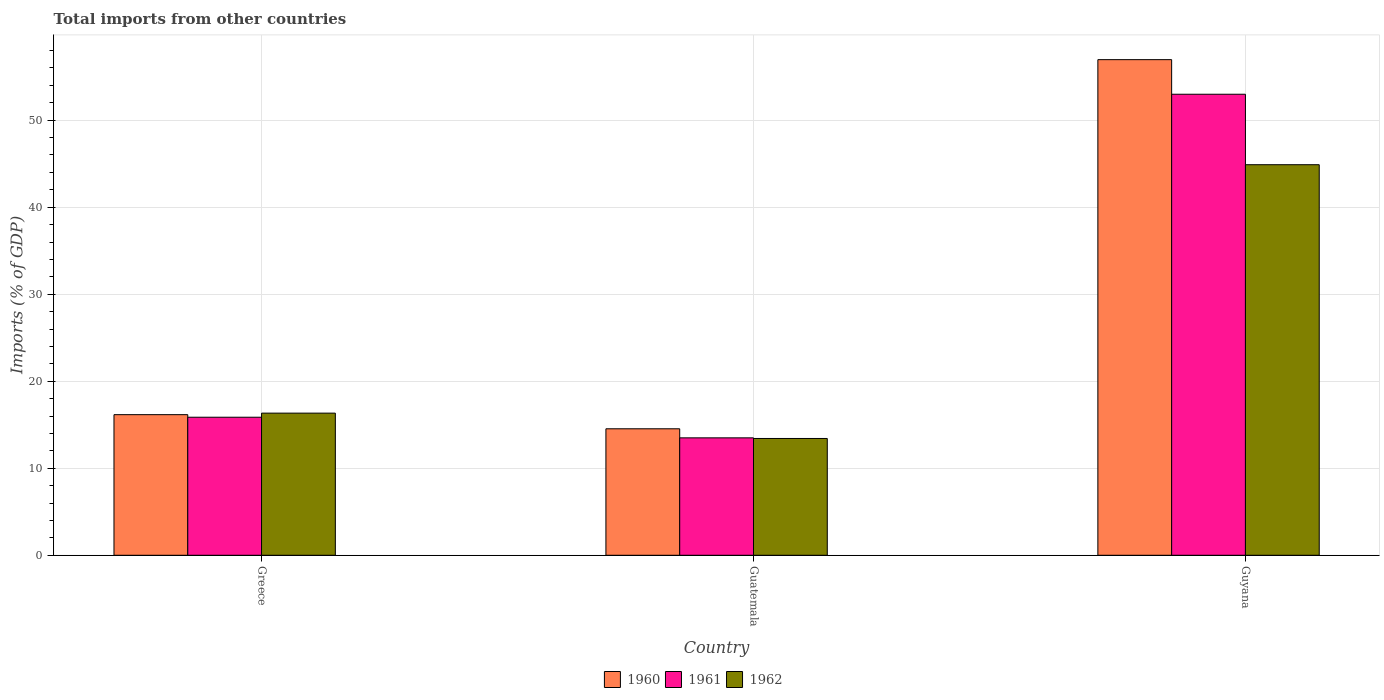How many different coloured bars are there?
Your answer should be compact. 3. How many groups of bars are there?
Your response must be concise. 3. How many bars are there on the 2nd tick from the right?
Ensure brevity in your answer.  3. What is the total imports in 1960 in Guatemala?
Make the answer very short. 14.54. Across all countries, what is the maximum total imports in 1962?
Provide a short and direct response. 44.88. Across all countries, what is the minimum total imports in 1961?
Keep it short and to the point. 13.49. In which country was the total imports in 1962 maximum?
Provide a succinct answer. Guyana. In which country was the total imports in 1960 minimum?
Your answer should be very brief. Guatemala. What is the total total imports in 1962 in the graph?
Your response must be concise. 74.64. What is the difference between the total imports in 1961 in Greece and that in Guatemala?
Keep it short and to the point. 2.37. What is the difference between the total imports in 1960 in Guyana and the total imports in 1961 in Greece?
Provide a short and direct response. 41.09. What is the average total imports in 1961 per country?
Your answer should be compact. 27.45. What is the difference between the total imports of/in 1962 and total imports of/in 1961 in Guatemala?
Your answer should be compact. -0.07. What is the ratio of the total imports in 1960 in Greece to that in Guyana?
Give a very brief answer. 0.28. Is the difference between the total imports in 1962 in Guatemala and Guyana greater than the difference between the total imports in 1961 in Guatemala and Guyana?
Offer a very short reply. Yes. What is the difference between the highest and the second highest total imports in 1960?
Provide a short and direct response. 40.8. What is the difference between the highest and the lowest total imports in 1961?
Ensure brevity in your answer.  39.49. In how many countries, is the total imports in 1960 greater than the average total imports in 1960 taken over all countries?
Keep it short and to the point. 1. Is the sum of the total imports in 1961 in Greece and Guyana greater than the maximum total imports in 1962 across all countries?
Give a very brief answer. Yes. What does the 1st bar from the left in Greece represents?
Provide a short and direct response. 1960. What does the 1st bar from the right in Greece represents?
Ensure brevity in your answer.  1962. Is it the case that in every country, the sum of the total imports in 1962 and total imports in 1961 is greater than the total imports in 1960?
Give a very brief answer. Yes. How many bars are there?
Your response must be concise. 9. Are all the bars in the graph horizontal?
Offer a very short reply. No. Does the graph contain any zero values?
Keep it short and to the point. No. Does the graph contain grids?
Offer a terse response. Yes. How are the legend labels stacked?
Your answer should be compact. Horizontal. What is the title of the graph?
Provide a succinct answer. Total imports from other countries. What is the label or title of the X-axis?
Offer a very short reply. Country. What is the label or title of the Y-axis?
Provide a succinct answer. Imports (% of GDP). What is the Imports (% of GDP) of 1960 in Greece?
Give a very brief answer. 16.16. What is the Imports (% of GDP) in 1961 in Greece?
Your answer should be very brief. 15.86. What is the Imports (% of GDP) in 1962 in Greece?
Your response must be concise. 16.33. What is the Imports (% of GDP) of 1960 in Guatemala?
Give a very brief answer. 14.54. What is the Imports (% of GDP) in 1961 in Guatemala?
Provide a succinct answer. 13.49. What is the Imports (% of GDP) in 1962 in Guatemala?
Keep it short and to the point. 13.42. What is the Imports (% of GDP) in 1960 in Guyana?
Your answer should be compact. 56.96. What is the Imports (% of GDP) of 1961 in Guyana?
Give a very brief answer. 52.98. What is the Imports (% of GDP) in 1962 in Guyana?
Provide a short and direct response. 44.88. Across all countries, what is the maximum Imports (% of GDP) in 1960?
Your response must be concise. 56.96. Across all countries, what is the maximum Imports (% of GDP) in 1961?
Your answer should be compact. 52.98. Across all countries, what is the maximum Imports (% of GDP) of 1962?
Offer a very short reply. 44.88. Across all countries, what is the minimum Imports (% of GDP) in 1960?
Offer a terse response. 14.54. Across all countries, what is the minimum Imports (% of GDP) in 1961?
Give a very brief answer. 13.49. Across all countries, what is the minimum Imports (% of GDP) of 1962?
Offer a very short reply. 13.42. What is the total Imports (% of GDP) of 1960 in the graph?
Your answer should be compact. 87.65. What is the total Imports (% of GDP) of 1961 in the graph?
Provide a succinct answer. 82.34. What is the total Imports (% of GDP) in 1962 in the graph?
Provide a succinct answer. 74.64. What is the difference between the Imports (% of GDP) of 1960 in Greece and that in Guatemala?
Make the answer very short. 1.62. What is the difference between the Imports (% of GDP) in 1961 in Greece and that in Guatemala?
Your answer should be compact. 2.37. What is the difference between the Imports (% of GDP) in 1962 in Greece and that in Guatemala?
Provide a succinct answer. 2.91. What is the difference between the Imports (% of GDP) in 1960 in Greece and that in Guyana?
Provide a short and direct response. -40.8. What is the difference between the Imports (% of GDP) in 1961 in Greece and that in Guyana?
Give a very brief answer. -37.12. What is the difference between the Imports (% of GDP) in 1962 in Greece and that in Guyana?
Your answer should be very brief. -28.55. What is the difference between the Imports (% of GDP) in 1960 in Guatemala and that in Guyana?
Offer a very short reply. -42.42. What is the difference between the Imports (% of GDP) of 1961 in Guatemala and that in Guyana?
Offer a very short reply. -39.49. What is the difference between the Imports (% of GDP) of 1962 in Guatemala and that in Guyana?
Offer a terse response. -31.46. What is the difference between the Imports (% of GDP) in 1960 in Greece and the Imports (% of GDP) in 1961 in Guatemala?
Your answer should be compact. 2.66. What is the difference between the Imports (% of GDP) in 1960 in Greece and the Imports (% of GDP) in 1962 in Guatemala?
Provide a short and direct response. 2.74. What is the difference between the Imports (% of GDP) of 1961 in Greece and the Imports (% of GDP) of 1962 in Guatemala?
Keep it short and to the point. 2.44. What is the difference between the Imports (% of GDP) of 1960 in Greece and the Imports (% of GDP) of 1961 in Guyana?
Ensure brevity in your answer.  -36.82. What is the difference between the Imports (% of GDP) of 1960 in Greece and the Imports (% of GDP) of 1962 in Guyana?
Offer a terse response. -28.72. What is the difference between the Imports (% of GDP) of 1961 in Greece and the Imports (% of GDP) of 1962 in Guyana?
Your response must be concise. -29.02. What is the difference between the Imports (% of GDP) of 1960 in Guatemala and the Imports (% of GDP) of 1961 in Guyana?
Offer a terse response. -38.45. What is the difference between the Imports (% of GDP) of 1960 in Guatemala and the Imports (% of GDP) of 1962 in Guyana?
Offer a very short reply. -30.35. What is the difference between the Imports (% of GDP) in 1961 in Guatemala and the Imports (% of GDP) in 1962 in Guyana?
Provide a succinct answer. -31.39. What is the average Imports (% of GDP) of 1960 per country?
Your answer should be very brief. 29.22. What is the average Imports (% of GDP) of 1961 per country?
Keep it short and to the point. 27.45. What is the average Imports (% of GDP) of 1962 per country?
Provide a succinct answer. 24.88. What is the difference between the Imports (% of GDP) in 1960 and Imports (% of GDP) in 1961 in Greece?
Give a very brief answer. 0.29. What is the difference between the Imports (% of GDP) in 1960 and Imports (% of GDP) in 1962 in Greece?
Ensure brevity in your answer.  -0.18. What is the difference between the Imports (% of GDP) in 1961 and Imports (% of GDP) in 1962 in Greece?
Keep it short and to the point. -0.47. What is the difference between the Imports (% of GDP) of 1960 and Imports (% of GDP) of 1961 in Guatemala?
Keep it short and to the point. 1.04. What is the difference between the Imports (% of GDP) of 1960 and Imports (% of GDP) of 1962 in Guatemala?
Your answer should be compact. 1.11. What is the difference between the Imports (% of GDP) of 1961 and Imports (% of GDP) of 1962 in Guatemala?
Offer a terse response. 0.07. What is the difference between the Imports (% of GDP) of 1960 and Imports (% of GDP) of 1961 in Guyana?
Give a very brief answer. 3.98. What is the difference between the Imports (% of GDP) in 1960 and Imports (% of GDP) in 1962 in Guyana?
Your answer should be compact. 12.07. What is the difference between the Imports (% of GDP) in 1961 and Imports (% of GDP) in 1962 in Guyana?
Keep it short and to the point. 8.1. What is the ratio of the Imports (% of GDP) in 1960 in Greece to that in Guatemala?
Offer a very short reply. 1.11. What is the ratio of the Imports (% of GDP) of 1961 in Greece to that in Guatemala?
Make the answer very short. 1.18. What is the ratio of the Imports (% of GDP) in 1962 in Greece to that in Guatemala?
Your answer should be compact. 1.22. What is the ratio of the Imports (% of GDP) in 1960 in Greece to that in Guyana?
Provide a short and direct response. 0.28. What is the ratio of the Imports (% of GDP) of 1961 in Greece to that in Guyana?
Provide a succinct answer. 0.3. What is the ratio of the Imports (% of GDP) of 1962 in Greece to that in Guyana?
Make the answer very short. 0.36. What is the ratio of the Imports (% of GDP) in 1960 in Guatemala to that in Guyana?
Offer a very short reply. 0.26. What is the ratio of the Imports (% of GDP) in 1961 in Guatemala to that in Guyana?
Make the answer very short. 0.25. What is the ratio of the Imports (% of GDP) of 1962 in Guatemala to that in Guyana?
Your response must be concise. 0.3. What is the difference between the highest and the second highest Imports (% of GDP) in 1960?
Keep it short and to the point. 40.8. What is the difference between the highest and the second highest Imports (% of GDP) in 1961?
Your response must be concise. 37.12. What is the difference between the highest and the second highest Imports (% of GDP) in 1962?
Offer a very short reply. 28.55. What is the difference between the highest and the lowest Imports (% of GDP) of 1960?
Your answer should be compact. 42.42. What is the difference between the highest and the lowest Imports (% of GDP) of 1961?
Give a very brief answer. 39.49. What is the difference between the highest and the lowest Imports (% of GDP) in 1962?
Offer a terse response. 31.46. 